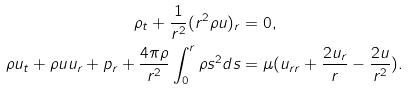Convert formula to latex. <formula><loc_0><loc_0><loc_500><loc_500>\rho _ { t } + \frac { 1 } { r ^ { 2 } } ( r ^ { 2 } \rho u ) _ { r } & = 0 , \\ \rho u _ { t } + \rho u u _ { r } + p _ { r } + \frac { 4 \pi \rho } { r ^ { 2 } } \int _ { 0 } ^ { r } \rho s ^ { 2 } d s & = \mu ( u _ { r r } + \frac { 2 u _ { r } } { r } - \frac { 2 u } { r ^ { 2 } } ) .</formula> 